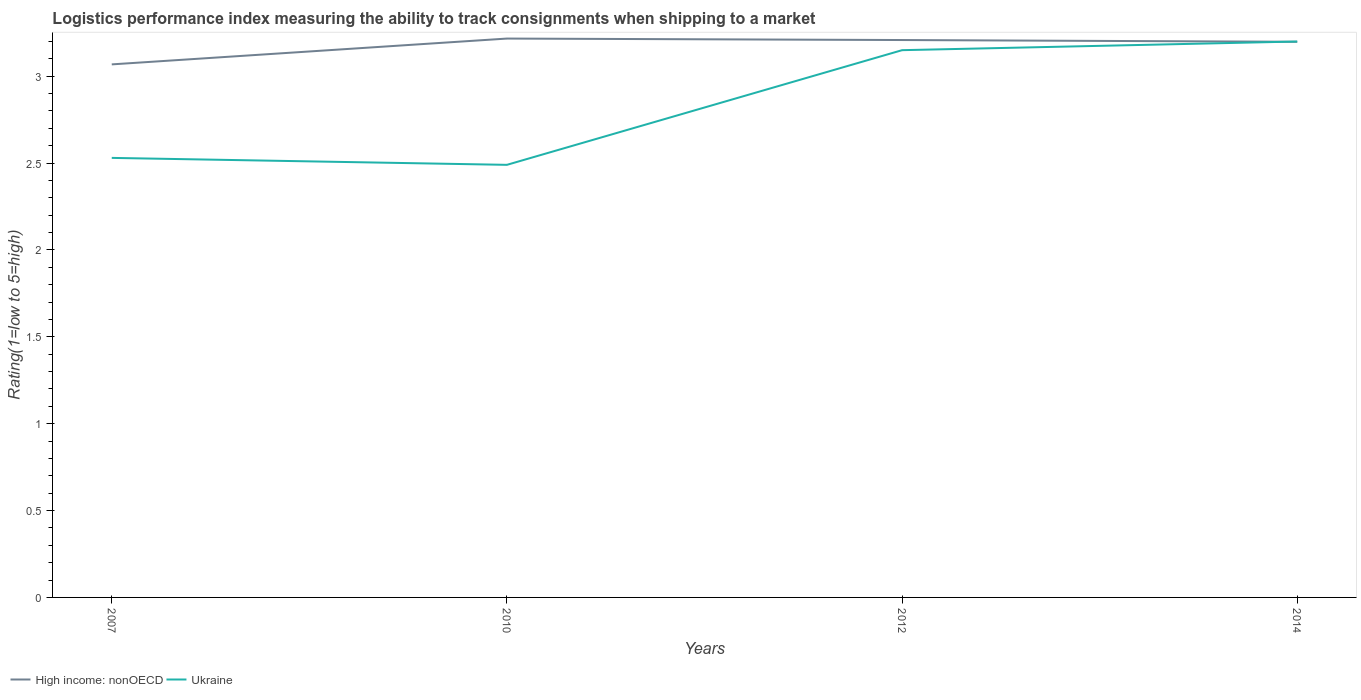Does the line corresponding to High income: nonOECD intersect with the line corresponding to Ukraine?
Provide a succinct answer. Yes. Across all years, what is the maximum Logistic performance index in Ukraine?
Provide a succinct answer. 2.49. In which year was the Logistic performance index in Ukraine maximum?
Keep it short and to the point. 2010. What is the total Logistic performance index in Ukraine in the graph?
Your answer should be compact. -0.66. What is the difference between the highest and the second highest Logistic performance index in High income: nonOECD?
Your answer should be compact. 0.15. What is the difference between the highest and the lowest Logistic performance index in High income: nonOECD?
Ensure brevity in your answer.  3. How many years are there in the graph?
Offer a terse response. 4. What is the difference between two consecutive major ticks on the Y-axis?
Make the answer very short. 0.5. Are the values on the major ticks of Y-axis written in scientific E-notation?
Offer a very short reply. No. Does the graph contain grids?
Offer a very short reply. No. Where does the legend appear in the graph?
Provide a short and direct response. Bottom left. What is the title of the graph?
Provide a short and direct response. Logistics performance index measuring the ability to track consignments when shipping to a market. Does "Paraguay" appear as one of the legend labels in the graph?
Make the answer very short. No. What is the label or title of the X-axis?
Offer a terse response. Years. What is the label or title of the Y-axis?
Make the answer very short. Rating(1=low to 5=high). What is the Rating(1=low to 5=high) of High income: nonOECD in 2007?
Ensure brevity in your answer.  3.07. What is the Rating(1=low to 5=high) in Ukraine in 2007?
Offer a very short reply. 2.53. What is the Rating(1=low to 5=high) of High income: nonOECD in 2010?
Offer a terse response. 3.22. What is the Rating(1=low to 5=high) in Ukraine in 2010?
Keep it short and to the point. 2.49. What is the Rating(1=low to 5=high) of High income: nonOECD in 2012?
Make the answer very short. 3.21. What is the Rating(1=low to 5=high) in Ukraine in 2012?
Your response must be concise. 3.15. What is the Rating(1=low to 5=high) of High income: nonOECD in 2014?
Keep it short and to the point. 3.2. What is the Rating(1=low to 5=high) in Ukraine in 2014?
Make the answer very short. 3.2. Across all years, what is the maximum Rating(1=low to 5=high) in High income: nonOECD?
Provide a succinct answer. 3.22. Across all years, what is the maximum Rating(1=low to 5=high) in Ukraine?
Make the answer very short. 3.2. Across all years, what is the minimum Rating(1=low to 5=high) in High income: nonOECD?
Your response must be concise. 3.07. Across all years, what is the minimum Rating(1=low to 5=high) in Ukraine?
Offer a terse response. 2.49. What is the total Rating(1=low to 5=high) of High income: nonOECD in the graph?
Give a very brief answer. 12.69. What is the total Rating(1=low to 5=high) of Ukraine in the graph?
Your answer should be compact. 11.37. What is the difference between the Rating(1=low to 5=high) in High income: nonOECD in 2007 and that in 2010?
Give a very brief answer. -0.15. What is the difference between the Rating(1=low to 5=high) in High income: nonOECD in 2007 and that in 2012?
Your answer should be very brief. -0.14. What is the difference between the Rating(1=low to 5=high) in Ukraine in 2007 and that in 2012?
Your response must be concise. -0.62. What is the difference between the Rating(1=low to 5=high) in High income: nonOECD in 2007 and that in 2014?
Your answer should be compact. -0.13. What is the difference between the Rating(1=low to 5=high) in Ukraine in 2007 and that in 2014?
Keep it short and to the point. -0.67. What is the difference between the Rating(1=low to 5=high) in High income: nonOECD in 2010 and that in 2012?
Provide a short and direct response. 0.01. What is the difference between the Rating(1=low to 5=high) of Ukraine in 2010 and that in 2012?
Your answer should be very brief. -0.66. What is the difference between the Rating(1=low to 5=high) in High income: nonOECD in 2010 and that in 2014?
Your response must be concise. 0.02. What is the difference between the Rating(1=low to 5=high) in Ukraine in 2010 and that in 2014?
Your response must be concise. -0.71. What is the difference between the Rating(1=low to 5=high) of High income: nonOECD in 2012 and that in 2014?
Your answer should be compact. 0.01. What is the difference between the Rating(1=low to 5=high) in Ukraine in 2012 and that in 2014?
Ensure brevity in your answer.  -0.05. What is the difference between the Rating(1=low to 5=high) in High income: nonOECD in 2007 and the Rating(1=low to 5=high) in Ukraine in 2010?
Provide a succinct answer. 0.58. What is the difference between the Rating(1=low to 5=high) of High income: nonOECD in 2007 and the Rating(1=low to 5=high) of Ukraine in 2012?
Provide a short and direct response. -0.08. What is the difference between the Rating(1=low to 5=high) of High income: nonOECD in 2007 and the Rating(1=low to 5=high) of Ukraine in 2014?
Make the answer very short. -0.13. What is the difference between the Rating(1=low to 5=high) of High income: nonOECD in 2010 and the Rating(1=low to 5=high) of Ukraine in 2012?
Offer a very short reply. 0.07. What is the difference between the Rating(1=low to 5=high) of High income: nonOECD in 2010 and the Rating(1=low to 5=high) of Ukraine in 2014?
Offer a terse response. 0.02. What is the difference between the Rating(1=low to 5=high) in High income: nonOECD in 2012 and the Rating(1=low to 5=high) in Ukraine in 2014?
Make the answer very short. 0.01. What is the average Rating(1=low to 5=high) of High income: nonOECD per year?
Make the answer very short. 3.17. What is the average Rating(1=low to 5=high) of Ukraine per year?
Your response must be concise. 2.84. In the year 2007, what is the difference between the Rating(1=low to 5=high) of High income: nonOECD and Rating(1=low to 5=high) of Ukraine?
Your answer should be compact. 0.54. In the year 2010, what is the difference between the Rating(1=low to 5=high) in High income: nonOECD and Rating(1=low to 5=high) in Ukraine?
Offer a terse response. 0.73. In the year 2012, what is the difference between the Rating(1=low to 5=high) of High income: nonOECD and Rating(1=low to 5=high) of Ukraine?
Provide a succinct answer. 0.06. In the year 2014, what is the difference between the Rating(1=low to 5=high) in High income: nonOECD and Rating(1=low to 5=high) in Ukraine?
Your answer should be very brief. -0. What is the ratio of the Rating(1=low to 5=high) of High income: nonOECD in 2007 to that in 2010?
Ensure brevity in your answer.  0.95. What is the ratio of the Rating(1=low to 5=high) of Ukraine in 2007 to that in 2010?
Provide a succinct answer. 1.02. What is the ratio of the Rating(1=low to 5=high) of High income: nonOECD in 2007 to that in 2012?
Offer a terse response. 0.96. What is the ratio of the Rating(1=low to 5=high) of Ukraine in 2007 to that in 2012?
Make the answer very short. 0.8. What is the ratio of the Rating(1=low to 5=high) of High income: nonOECD in 2007 to that in 2014?
Provide a succinct answer. 0.96. What is the ratio of the Rating(1=low to 5=high) of Ukraine in 2007 to that in 2014?
Keep it short and to the point. 0.79. What is the ratio of the Rating(1=low to 5=high) of High income: nonOECD in 2010 to that in 2012?
Offer a terse response. 1. What is the ratio of the Rating(1=low to 5=high) in Ukraine in 2010 to that in 2012?
Make the answer very short. 0.79. What is the ratio of the Rating(1=low to 5=high) in Ukraine in 2010 to that in 2014?
Offer a terse response. 0.78. What is the ratio of the Rating(1=low to 5=high) in Ukraine in 2012 to that in 2014?
Ensure brevity in your answer.  0.98. What is the difference between the highest and the second highest Rating(1=low to 5=high) in High income: nonOECD?
Ensure brevity in your answer.  0.01. What is the difference between the highest and the second highest Rating(1=low to 5=high) of Ukraine?
Make the answer very short. 0.05. What is the difference between the highest and the lowest Rating(1=low to 5=high) in High income: nonOECD?
Provide a short and direct response. 0.15. What is the difference between the highest and the lowest Rating(1=low to 5=high) in Ukraine?
Keep it short and to the point. 0.71. 